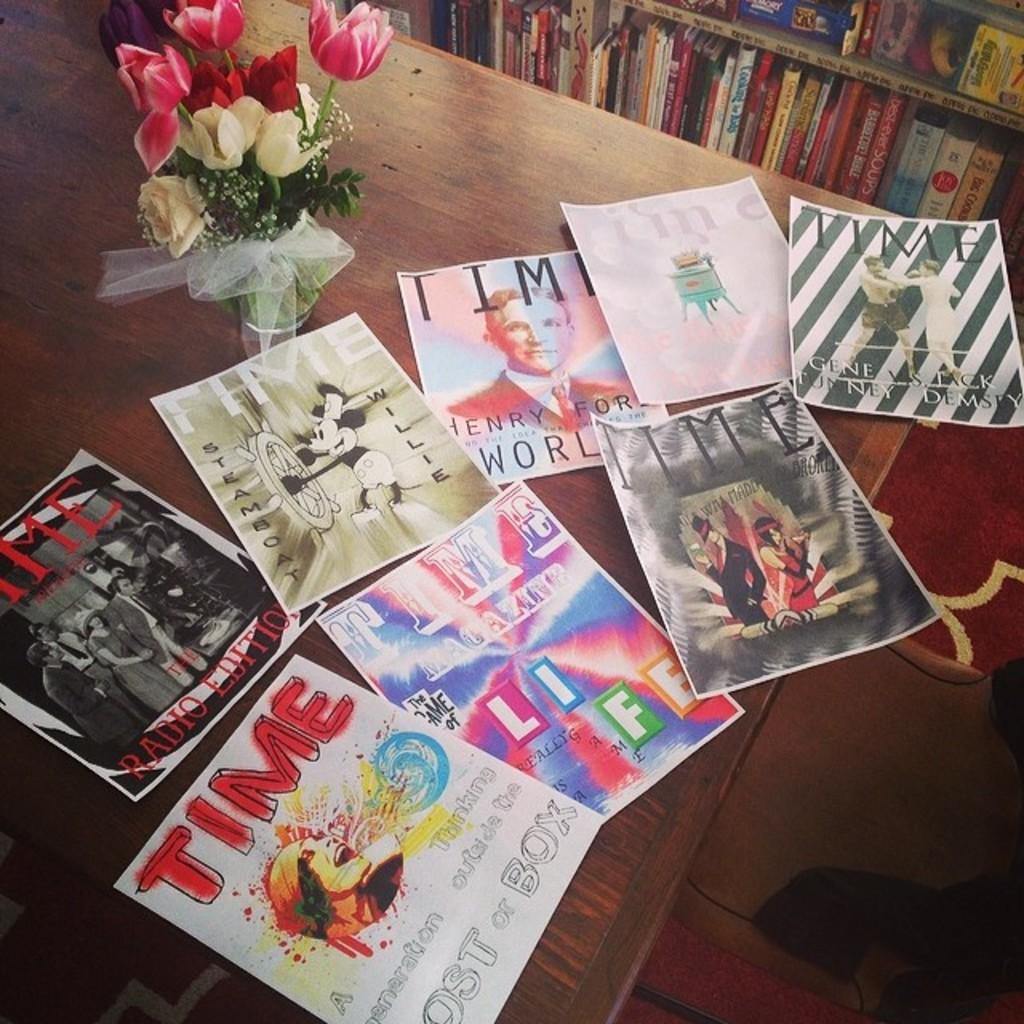What´s the name of the author on the first picture on top?
Provide a short and direct response. Unanswerable. 